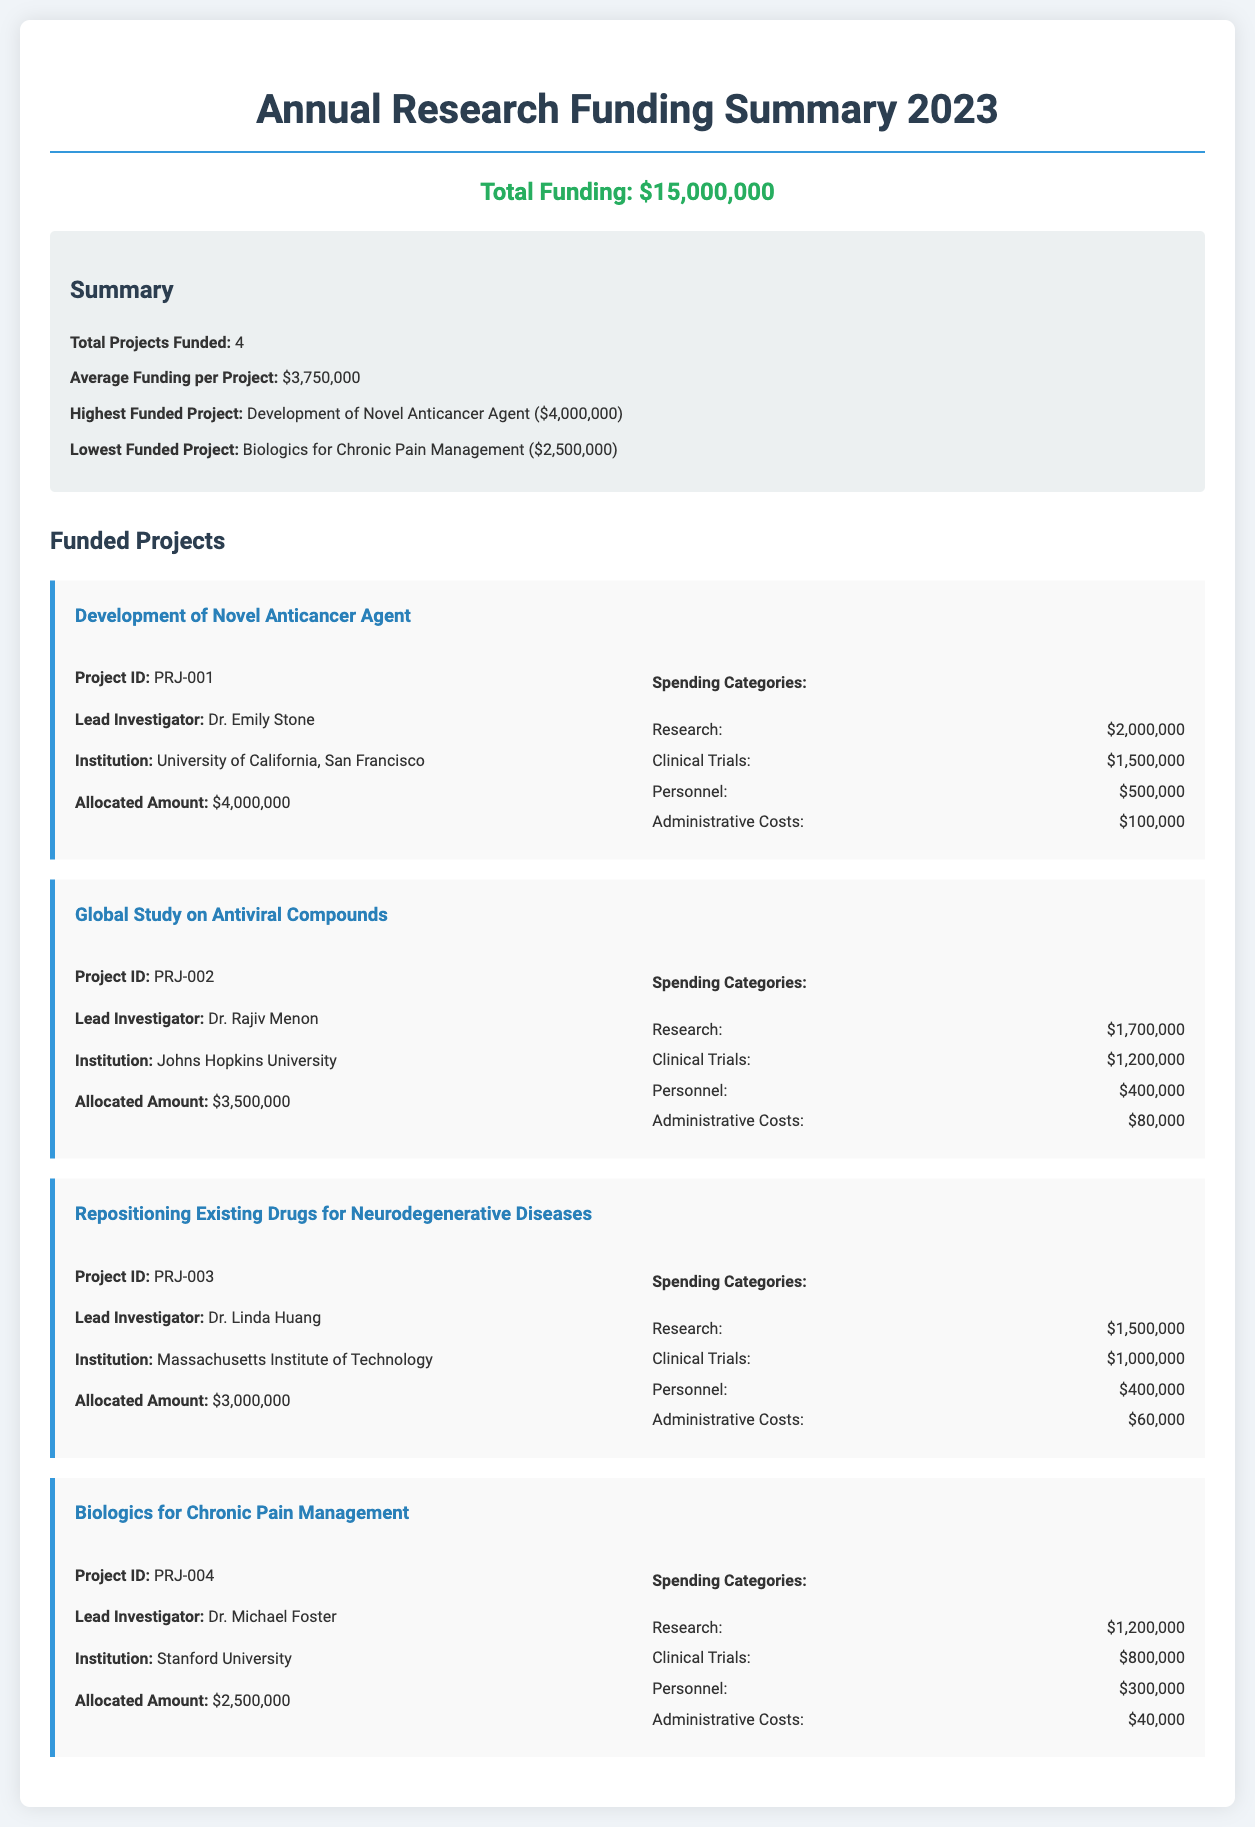what is the total funding? The total funding indicated in the document is explicitly stated in the total funding section as $15,000,000.
Answer: $15,000,000 how many projects were funded? The document includes a summary section that specifies the total number of projects funded as 4.
Answer: 4 who is the lead investigator for the highest funded project? The highest funded project is "Development of Novel Anticancer Agent," and the project details list Dr. Emily Stone as the lead investigator.
Answer: Dr. Emily Stone what is the lowest funded project? The document identifies "Biologics for Chronic Pain Management" as the lowest funded project along with its allocated amount.
Answer: Biologics for Chronic Pain Management how much was allocated to clinical trials for the Global Study on Antiviral Compounds? The project details for the Global Study on Antiviral Compounds specify that $1,200,000 was allocated for clinical trials.
Answer: $1,200,000 what percentage of the total funding was allocated to research for the Development of Novel Anticancer Agent? The allocated amount for research in this project is $2,000,000, which is a component of the total funding; calculations show it is 13.33% of the total funding.
Answer: 13.33% which institution leads the project on Repositioning Existing Drugs for Neurodegenerative Diseases? The document specifies that the Massachusetts Institute of Technology is the institution associated with the project on Repositioning Existing Drugs for Neurodegenerative Diseases.
Answer: Massachusetts Institute of Technology how much total funding was allocated to personnel across all projects? The document outlines personnel allocations for each project, totaling $500,000 + $400,000 + $400,000 + $300,000 = $1,600,000 across all projects.
Answer: $1,600,000 what spending category received the highest allocation for the Biologics for Chronic Pain Management project? Within the spending categories for the Biologics for Chronic Pain Management project, research received the highest allocation at $1,200,000.
Answer: Research 